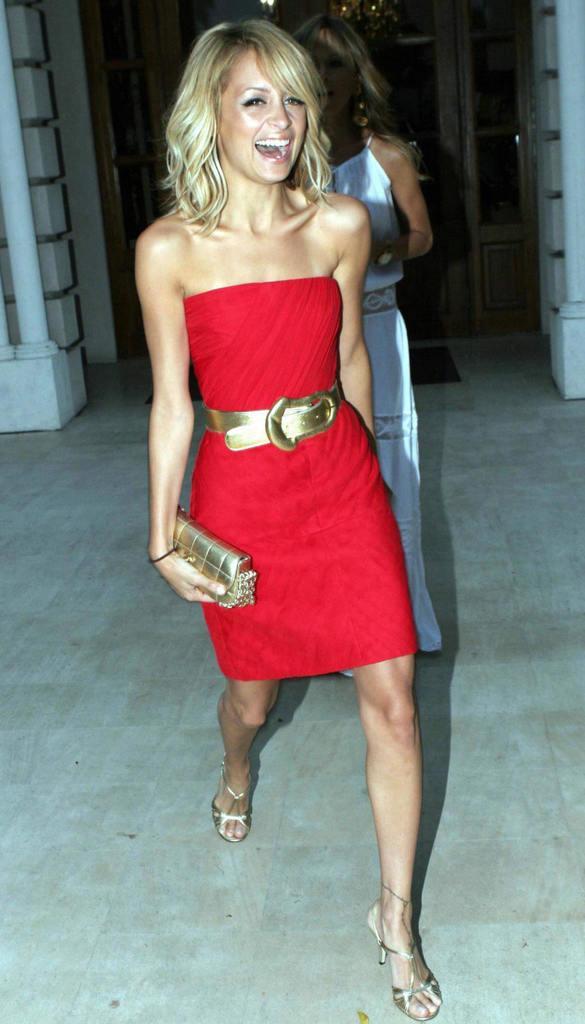Can you describe this image briefly? In this image we can see two women standing on the ground. One woman is holding a bag in her hand. In the background, we can see a building with doors. 